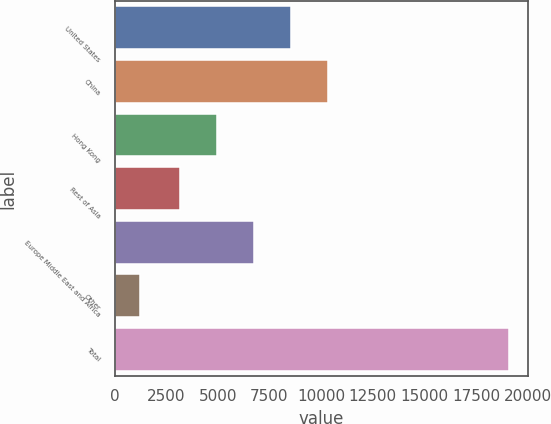Convert chart. <chart><loc_0><loc_0><loc_500><loc_500><bar_chart><fcel>United States<fcel>China<fcel>Hong Kong<fcel>Rest of Asia<fcel>Europe Middle East and Africa<fcel>Other<fcel>Total<nl><fcel>8540.8<fcel>10327.4<fcel>4967.6<fcel>3181<fcel>6754.2<fcel>1227<fcel>19093<nl></chart> 